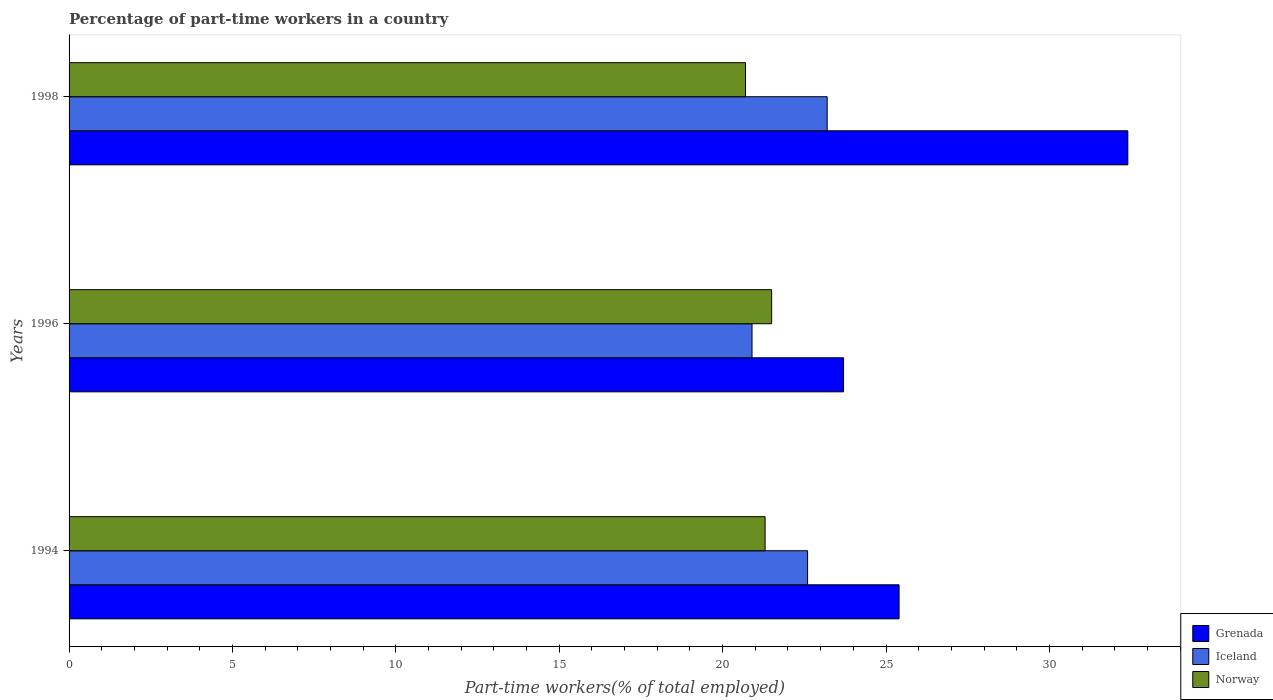How many different coloured bars are there?
Ensure brevity in your answer.  3. How many groups of bars are there?
Ensure brevity in your answer.  3. In how many cases, is the number of bars for a given year not equal to the number of legend labels?
Make the answer very short. 0. Across all years, what is the maximum percentage of part-time workers in Iceland?
Your response must be concise. 23.2. Across all years, what is the minimum percentage of part-time workers in Iceland?
Offer a terse response. 20.9. In which year was the percentage of part-time workers in Grenada minimum?
Offer a terse response. 1996. What is the total percentage of part-time workers in Iceland in the graph?
Ensure brevity in your answer.  66.7. What is the difference between the percentage of part-time workers in Grenada in 1994 and that in 1996?
Provide a succinct answer. 1.7. What is the average percentage of part-time workers in Grenada per year?
Keep it short and to the point. 27.17. What is the ratio of the percentage of part-time workers in Iceland in 1996 to that in 1998?
Your answer should be compact. 0.9. Is the percentage of part-time workers in Grenada in 1994 less than that in 1996?
Make the answer very short. No. What is the difference between the highest and the second highest percentage of part-time workers in Iceland?
Keep it short and to the point. 0.6. What is the difference between the highest and the lowest percentage of part-time workers in Norway?
Your answer should be compact. 0.8. Is the sum of the percentage of part-time workers in Norway in 1996 and 1998 greater than the maximum percentage of part-time workers in Grenada across all years?
Your answer should be compact. Yes. What does the 2nd bar from the bottom in 1994 represents?
Offer a terse response. Iceland. How many years are there in the graph?
Your answer should be very brief. 3. How many legend labels are there?
Give a very brief answer. 3. What is the title of the graph?
Provide a succinct answer. Percentage of part-time workers in a country. Does "Spain" appear as one of the legend labels in the graph?
Your response must be concise. No. What is the label or title of the X-axis?
Your answer should be very brief. Part-time workers(% of total employed). What is the Part-time workers(% of total employed) of Grenada in 1994?
Keep it short and to the point. 25.4. What is the Part-time workers(% of total employed) in Iceland in 1994?
Your answer should be very brief. 22.6. What is the Part-time workers(% of total employed) in Norway in 1994?
Keep it short and to the point. 21.3. What is the Part-time workers(% of total employed) in Grenada in 1996?
Your answer should be compact. 23.7. What is the Part-time workers(% of total employed) of Iceland in 1996?
Your answer should be very brief. 20.9. What is the Part-time workers(% of total employed) of Grenada in 1998?
Make the answer very short. 32.4. What is the Part-time workers(% of total employed) of Iceland in 1998?
Offer a terse response. 23.2. What is the Part-time workers(% of total employed) of Norway in 1998?
Your response must be concise. 20.7. Across all years, what is the maximum Part-time workers(% of total employed) in Grenada?
Give a very brief answer. 32.4. Across all years, what is the maximum Part-time workers(% of total employed) in Iceland?
Your answer should be very brief. 23.2. Across all years, what is the maximum Part-time workers(% of total employed) of Norway?
Provide a succinct answer. 21.5. Across all years, what is the minimum Part-time workers(% of total employed) of Grenada?
Your answer should be very brief. 23.7. Across all years, what is the minimum Part-time workers(% of total employed) in Iceland?
Provide a succinct answer. 20.9. Across all years, what is the minimum Part-time workers(% of total employed) of Norway?
Provide a succinct answer. 20.7. What is the total Part-time workers(% of total employed) of Grenada in the graph?
Offer a terse response. 81.5. What is the total Part-time workers(% of total employed) of Iceland in the graph?
Offer a very short reply. 66.7. What is the total Part-time workers(% of total employed) in Norway in the graph?
Your answer should be very brief. 63.5. What is the difference between the Part-time workers(% of total employed) of Grenada in 1994 and that in 1996?
Keep it short and to the point. 1.7. What is the difference between the Part-time workers(% of total employed) of Grenada in 1994 and that in 1998?
Offer a terse response. -7. What is the difference between the Part-time workers(% of total employed) of Iceland in 1996 and that in 1998?
Ensure brevity in your answer.  -2.3. What is the difference between the Part-time workers(% of total employed) of Norway in 1996 and that in 1998?
Give a very brief answer. 0.8. What is the difference between the Part-time workers(% of total employed) of Grenada in 1994 and the Part-time workers(% of total employed) of Norway in 1996?
Your response must be concise. 3.9. What is the difference between the Part-time workers(% of total employed) of Iceland in 1994 and the Part-time workers(% of total employed) of Norway in 1998?
Offer a terse response. 1.9. What is the difference between the Part-time workers(% of total employed) of Iceland in 1996 and the Part-time workers(% of total employed) of Norway in 1998?
Your answer should be very brief. 0.2. What is the average Part-time workers(% of total employed) in Grenada per year?
Ensure brevity in your answer.  27.17. What is the average Part-time workers(% of total employed) of Iceland per year?
Provide a succinct answer. 22.23. What is the average Part-time workers(% of total employed) of Norway per year?
Provide a short and direct response. 21.17. In the year 1994, what is the difference between the Part-time workers(% of total employed) of Grenada and Part-time workers(% of total employed) of Iceland?
Offer a very short reply. 2.8. In the year 1994, what is the difference between the Part-time workers(% of total employed) in Grenada and Part-time workers(% of total employed) in Norway?
Keep it short and to the point. 4.1. In the year 1994, what is the difference between the Part-time workers(% of total employed) of Iceland and Part-time workers(% of total employed) of Norway?
Offer a very short reply. 1.3. In the year 1996, what is the difference between the Part-time workers(% of total employed) in Iceland and Part-time workers(% of total employed) in Norway?
Give a very brief answer. -0.6. In the year 1998, what is the difference between the Part-time workers(% of total employed) in Grenada and Part-time workers(% of total employed) in Iceland?
Your answer should be very brief. 9.2. In the year 1998, what is the difference between the Part-time workers(% of total employed) of Grenada and Part-time workers(% of total employed) of Norway?
Your response must be concise. 11.7. In the year 1998, what is the difference between the Part-time workers(% of total employed) of Iceland and Part-time workers(% of total employed) of Norway?
Provide a succinct answer. 2.5. What is the ratio of the Part-time workers(% of total employed) of Grenada in 1994 to that in 1996?
Your answer should be very brief. 1.07. What is the ratio of the Part-time workers(% of total employed) in Iceland in 1994 to that in 1996?
Offer a terse response. 1.08. What is the ratio of the Part-time workers(% of total employed) in Norway in 1994 to that in 1996?
Your answer should be compact. 0.99. What is the ratio of the Part-time workers(% of total employed) of Grenada in 1994 to that in 1998?
Your answer should be very brief. 0.78. What is the ratio of the Part-time workers(% of total employed) of Iceland in 1994 to that in 1998?
Offer a terse response. 0.97. What is the ratio of the Part-time workers(% of total employed) in Grenada in 1996 to that in 1998?
Your answer should be compact. 0.73. What is the ratio of the Part-time workers(% of total employed) in Iceland in 1996 to that in 1998?
Your response must be concise. 0.9. What is the ratio of the Part-time workers(% of total employed) in Norway in 1996 to that in 1998?
Provide a succinct answer. 1.04. What is the difference between the highest and the second highest Part-time workers(% of total employed) in Iceland?
Your answer should be very brief. 0.6. What is the difference between the highest and the lowest Part-time workers(% of total employed) in Grenada?
Provide a short and direct response. 8.7. What is the difference between the highest and the lowest Part-time workers(% of total employed) in Iceland?
Offer a very short reply. 2.3. What is the difference between the highest and the lowest Part-time workers(% of total employed) of Norway?
Make the answer very short. 0.8. 